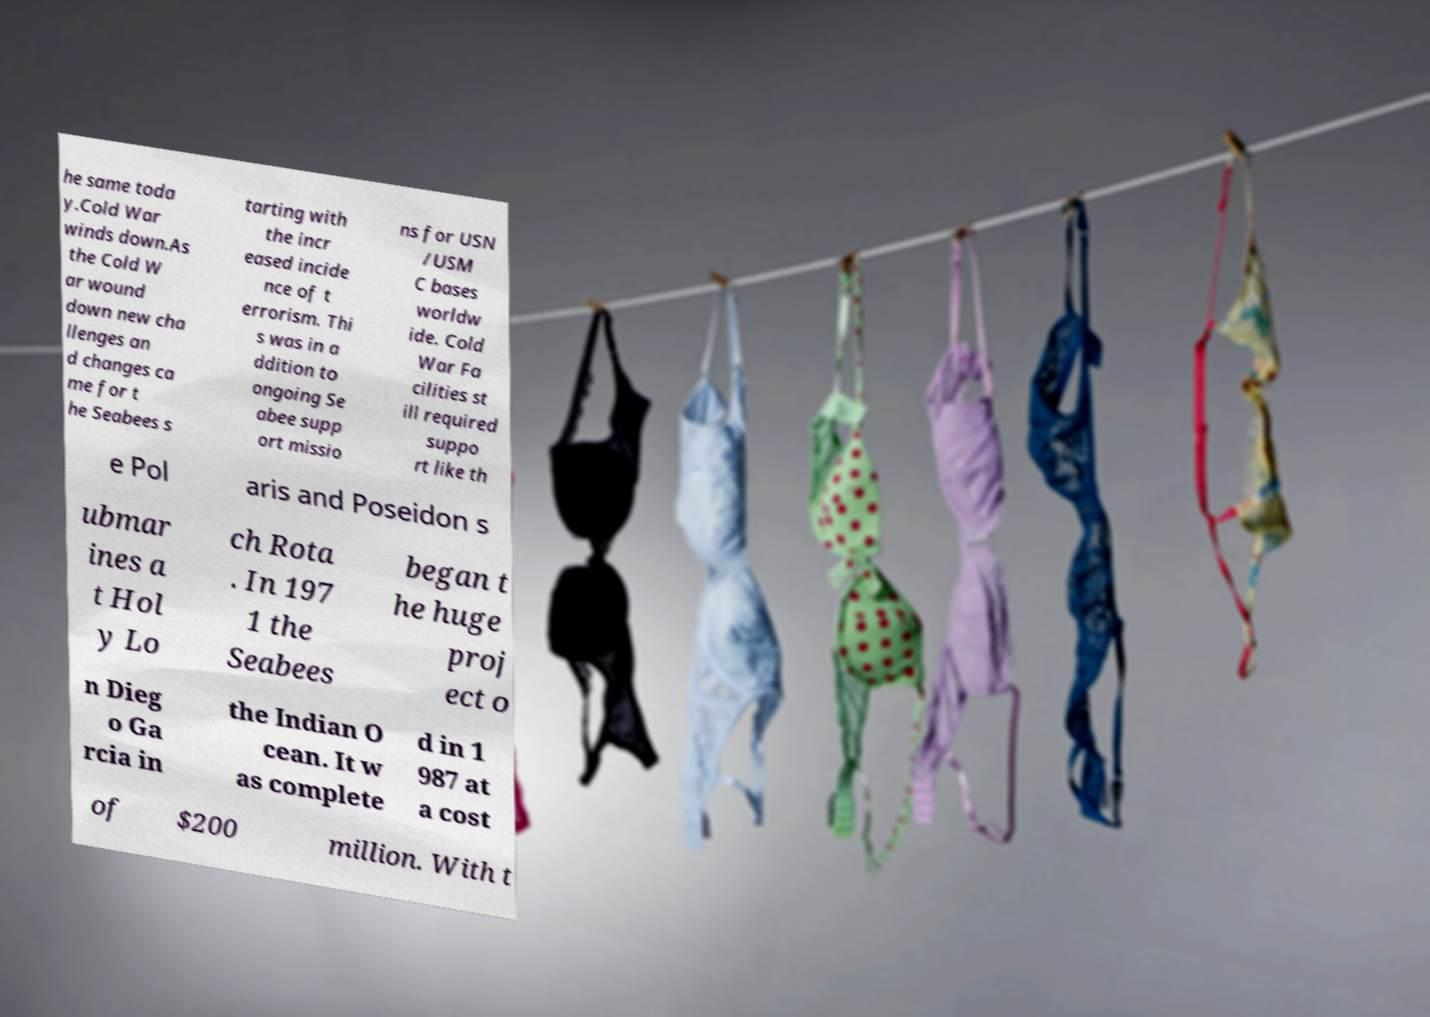Could you extract and type out the text from this image? he same toda y.Cold War winds down.As the Cold W ar wound down new cha llenges an d changes ca me for t he Seabees s tarting with the incr eased incide nce of t errorism. Thi s was in a ddition to ongoing Se abee supp ort missio ns for USN /USM C bases worldw ide. Cold War Fa cilities st ill required suppo rt like th e Pol aris and Poseidon s ubmar ines a t Hol y Lo ch Rota . In 197 1 the Seabees began t he huge proj ect o n Dieg o Ga rcia in the Indian O cean. It w as complete d in 1 987 at a cost of $200 million. With t 